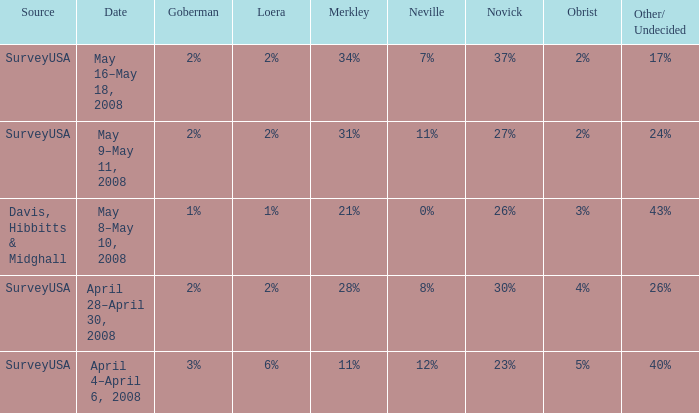I'm looking to parse the entire table for insights. Could you assist me with that? {'header': ['Source', 'Date', 'Goberman', 'Loera', 'Merkley', 'Neville', 'Novick', 'Obrist', 'Other/ Undecided'], 'rows': [['SurveyUSA', 'May 16–May 18, 2008', '2%', '2%', '34%', '7%', '37%', '2%', '17%'], ['SurveyUSA', 'May 9–May 11, 2008', '2%', '2%', '31%', '11%', '27%', '2%', '24%'], ['Davis, Hibbitts & Midghall', 'May 8–May 10, 2008', '1%', '1%', '21%', '0%', '26%', '3%', '43%'], ['SurveyUSA', 'April 28–April 30, 2008', '2%', '2%', '28%', '8%', '30%', '4%', '26%'], ['SurveyUSA', 'April 4–April 6, 2008', '3%', '6%', '11%', '12%', '23%', '5%', '40%']]} Which Novick has a Source of surveyusa, and a Neville of 8%? 30%. 